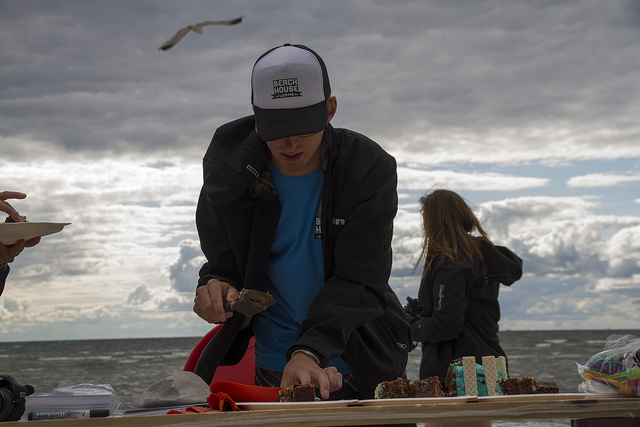What is the person in the foreground doing? The person in the foreground seems to be slicing what could be a cake or some dessert on a table, likely serving it to others around them. 